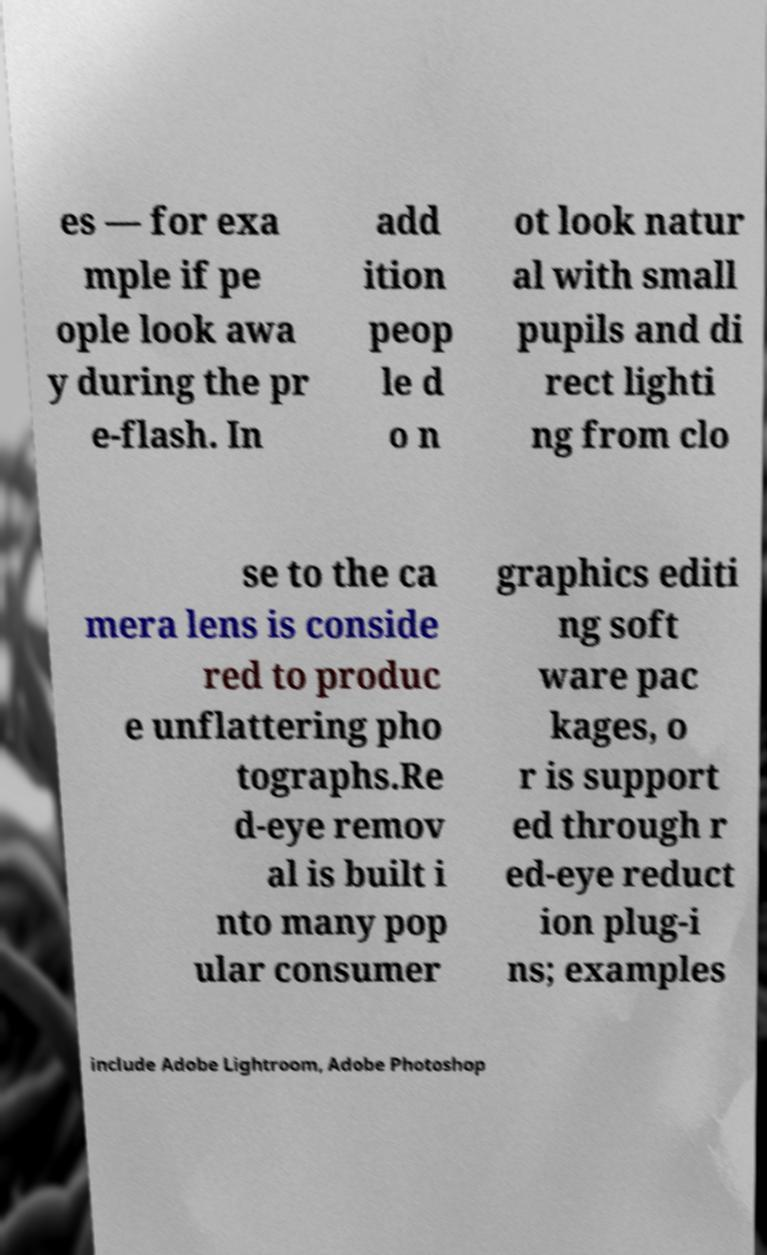There's text embedded in this image that I need extracted. Can you transcribe it verbatim? es — for exa mple if pe ople look awa y during the pr e-flash. In add ition peop le d o n ot look natur al with small pupils and di rect lighti ng from clo se to the ca mera lens is conside red to produc e unflattering pho tographs.Re d-eye remov al is built i nto many pop ular consumer graphics editi ng soft ware pac kages, o r is support ed through r ed-eye reduct ion plug-i ns; examples include Adobe Lightroom, Adobe Photoshop 